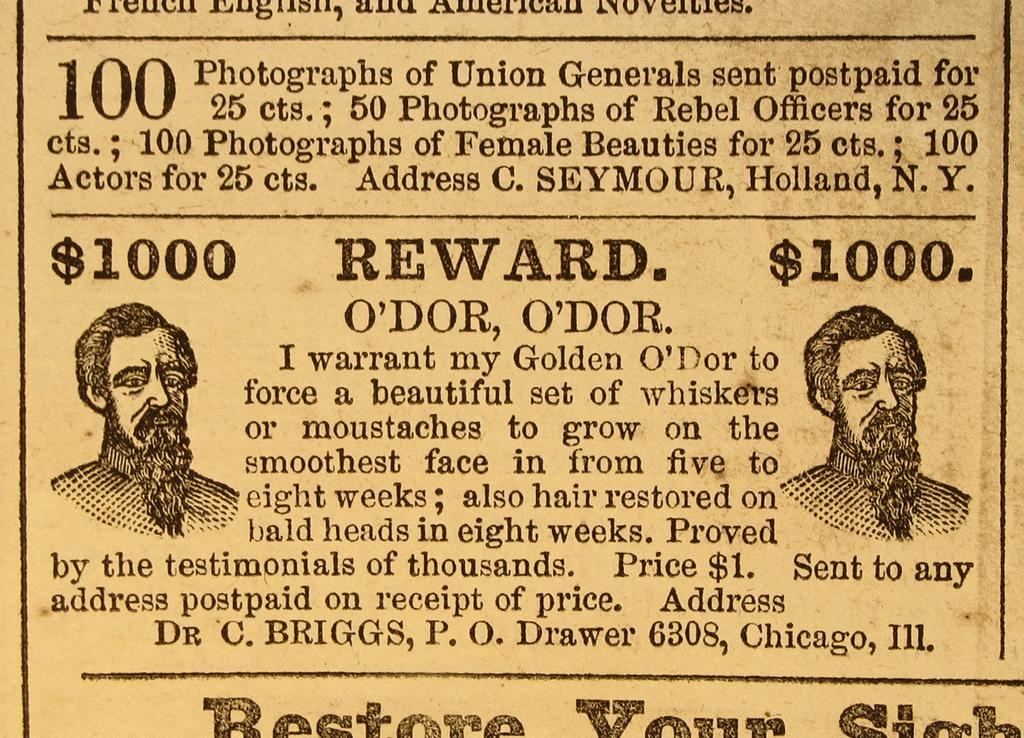Please provide a concise description of this image. In this picture there is a yellow color magazine paper on which some quote is written. 